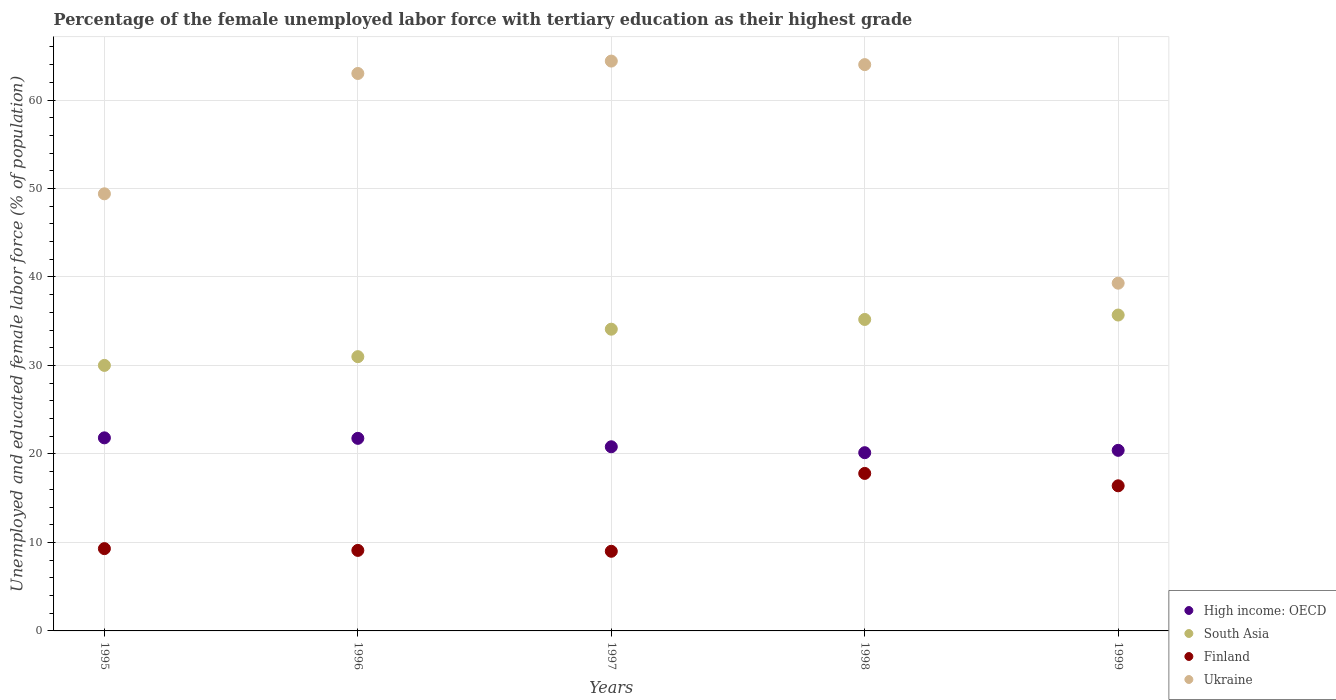How many different coloured dotlines are there?
Your answer should be compact. 4. What is the percentage of the unemployed female labor force with tertiary education in Finland in 1996?
Keep it short and to the point. 9.1. Across all years, what is the maximum percentage of the unemployed female labor force with tertiary education in High income: OECD?
Keep it short and to the point. 21.82. Across all years, what is the minimum percentage of the unemployed female labor force with tertiary education in South Asia?
Ensure brevity in your answer.  30.01. In which year was the percentage of the unemployed female labor force with tertiary education in South Asia maximum?
Offer a terse response. 1999. What is the total percentage of the unemployed female labor force with tertiary education in High income: OECD in the graph?
Give a very brief answer. 104.95. What is the difference between the percentage of the unemployed female labor force with tertiary education in High income: OECD in 1995 and that in 1999?
Keep it short and to the point. 1.41. What is the difference between the percentage of the unemployed female labor force with tertiary education in Finland in 1999 and the percentage of the unemployed female labor force with tertiary education in High income: OECD in 1996?
Your response must be concise. -5.36. What is the average percentage of the unemployed female labor force with tertiary education in High income: OECD per year?
Make the answer very short. 20.99. In the year 1999, what is the difference between the percentage of the unemployed female labor force with tertiary education in High income: OECD and percentage of the unemployed female labor force with tertiary education in Finland?
Your response must be concise. 4.01. What is the ratio of the percentage of the unemployed female labor force with tertiary education in Ukraine in 1997 to that in 1998?
Ensure brevity in your answer.  1.01. Is the percentage of the unemployed female labor force with tertiary education in High income: OECD in 1997 less than that in 1999?
Provide a succinct answer. No. Is the difference between the percentage of the unemployed female labor force with tertiary education in High income: OECD in 1996 and 1997 greater than the difference between the percentage of the unemployed female labor force with tertiary education in Finland in 1996 and 1997?
Offer a very short reply. Yes. What is the difference between the highest and the second highest percentage of the unemployed female labor force with tertiary education in South Asia?
Your answer should be compact. 0.5. What is the difference between the highest and the lowest percentage of the unemployed female labor force with tertiary education in High income: OECD?
Offer a terse response. 1.68. In how many years, is the percentage of the unemployed female labor force with tertiary education in High income: OECD greater than the average percentage of the unemployed female labor force with tertiary education in High income: OECD taken over all years?
Ensure brevity in your answer.  2. Is the sum of the percentage of the unemployed female labor force with tertiary education in Ukraine in 1995 and 1999 greater than the maximum percentage of the unemployed female labor force with tertiary education in High income: OECD across all years?
Provide a succinct answer. Yes. How many dotlines are there?
Keep it short and to the point. 4. How many years are there in the graph?
Give a very brief answer. 5. Does the graph contain any zero values?
Make the answer very short. No. How many legend labels are there?
Your response must be concise. 4. What is the title of the graph?
Make the answer very short. Percentage of the female unemployed labor force with tertiary education as their highest grade. What is the label or title of the Y-axis?
Offer a very short reply. Unemployed and educated female labor force (% of population). What is the Unemployed and educated female labor force (% of population) in High income: OECD in 1995?
Your response must be concise. 21.82. What is the Unemployed and educated female labor force (% of population) of South Asia in 1995?
Provide a short and direct response. 30.01. What is the Unemployed and educated female labor force (% of population) of Finland in 1995?
Make the answer very short. 9.3. What is the Unemployed and educated female labor force (% of population) in Ukraine in 1995?
Make the answer very short. 49.4. What is the Unemployed and educated female labor force (% of population) of High income: OECD in 1996?
Offer a very short reply. 21.76. What is the Unemployed and educated female labor force (% of population) in South Asia in 1996?
Keep it short and to the point. 30.99. What is the Unemployed and educated female labor force (% of population) in Finland in 1996?
Ensure brevity in your answer.  9.1. What is the Unemployed and educated female labor force (% of population) in Ukraine in 1996?
Provide a succinct answer. 63. What is the Unemployed and educated female labor force (% of population) of High income: OECD in 1997?
Offer a terse response. 20.81. What is the Unemployed and educated female labor force (% of population) in South Asia in 1997?
Your response must be concise. 34.1. What is the Unemployed and educated female labor force (% of population) in Ukraine in 1997?
Give a very brief answer. 64.4. What is the Unemployed and educated female labor force (% of population) of High income: OECD in 1998?
Provide a succinct answer. 20.14. What is the Unemployed and educated female labor force (% of population) of South Asia in 1998?
Give a very brief answer. 35.2. What is the Unemployed and educated female labor force (% of population) of Finland in 1998?
Provide a succinct answer. 17.8. What is the Unemployed and educated female labor force (% of population) of High income: OECD in 1999?
Offer a very short reply. 20.41. What is the Unemployed and educated female labor force (% of population) in South Asia in 1999?
Ensure brevity in your answer.  35.7. What is the Unemployed and educated female labor force (% of population) in Finland in 1999?
Offer a very short reply. 16.4. What is the Unemployed and educated female labor force (% of population) in Ukraine in 1999?
Your answer should be very brief. 39.3. Across all years, what is the maximum Unemployed and educated female labor force (% of population) in High income: OECD?
Provide a short and direct response. 21.82. Across all years, what is the maximum Unemployed and educated female labor force (% of population) in South Asia?
Ensure brevity in your answer.  35.7. Across all years, what is the maximum Unemployed and educated female labor force (% of population) of Finland?
Give a very brief answer. 17.8. Across all years, what is the maximum Unemployed and educated female labor force (% of population) of Ukraine?
Provide a succinct answer. 64.4. Across all years, what is the minimum Unemployed and educated female labor force (% of population) of High income: OECD?
Keep it short and to the point. 20.14. Across all years, what is the minimum Unemployed and educated female labor force (% of population) in South Asia?
Your answer should be compact. 30.01. Across all years, what is the minimum Unemployed and educated female labor force (% of population) of Finland?
Offer a terse response. 9. Across all years, what is the minimum Unemployed and educated female labor force (% of population) in Ukraine?
Ensure brevity in your answer.  39.3. What is the total Unemployed and educated female labor force (% of population) of High income: OECD in the graph?
Offer a very short reply. 104.95. What is the total Unemployed and educated female labor force (% of population) of South Asia in the graph?
Your answer should be compact. 166. What is the total Unemployed and educated female labor force (% of population) of Finland in the graph?
Provide a short and direct response. 61.6. What is the total Unemployed and educated female labor force (% of population) of Ukraine in the graph?
Your answer should be very brief. 280.1. What is the difference between the Unemployed and educated female labor force (% of population) in High income: OECD in 1995 and that in 1996?
Ensure brevity in your answer.  0.06. What is the difference between the Unemployed and educated female labor force (% of population) of South Asia in 1995 and that in 1996?
Your answer should be very brief. -0.99. What is the difference between the Unemployed and educated female labor force (% of population) of High income: OECD in 1995 and that in 1997?
Offer a terse response. 1.01. What is the difference between the Unemployed and educated female labor force (% of population) in South Asia in 1995 and that in 1997?
Provide a succinct answer. -4.09. What is the difference between the Unemployed and educated female labor force (% of population) of Finland in 1995 and that in 1997?
Provide a short and direct response. 0.3. What is the difference between the Unemployed and educated female labor force (% of population) in High income: OECD in 1995 and that in 1998?
Provide a short and direct response. 1.68. What is the difference between the Unemployed and educated female labor force (% of population) in South Asia in 1995 and that in 1998?
Provide a short and direct response. -5.19. What is the difference between the Unemployed and educated female labor force (% of population) in Finland in 1995 and that in 1998?
Your answer should be compact. -8.5. What is the difference between the Unemployed and educated female labor force (% of population) of Ukraine in 1995 and that in 1998?
Offer a terse response. -14.6. What is the difference between the Unemployed and educated female labor force (% of population) in High income: OECD in 1995 and that in 1999?
Your answer should be very brief. 1.41. What is the difference between the Unemployed and educated female labor force (% of population) in South Asia in 1995 and that in 1999?
Your answer should be very brief. -5.69. What is the difference between the Unemployed and educated female labor force (% of population) of High income: OECD in 1996 and that in 1997?
Your answer should be compact. 0.95. What is the difference between the Unemployed and educated female labor force (% of population) of South Asia in 1996 and that in 1997?
Provide a short and direct response. -3.11. What is the difference between the Unemployed and educated female labor force (% of population) of Finland in 1996 and that in 1997?
Offer a very short reply. 0.1. What is the difference between the Unemployed and educated female labor force (% of population) of Ukraine in 1996 and that in 1997?
Ensure brevity in your answer.  -1.4. What is the difference between the Unemployed and educated female labor force (% of population) in High income: OECD in 1996 and that in 1998?
Provide a short and direct response. 1.62. What is the difference between the Unemployed and educated female labor force (% of population) in South Asia in 1996 and that in 1998?
Provide a short and direct response. -4.21. What is the difference between the Unemployed and educated female labor force (% of population) of Ukraine in 1996 and that in 1998?
Provide a succinct answer. -1. What is the difference between the Unemployed and educated female labor force (% of population) of High income: OECD in 1996 and that in 1999?
Provide a short and direct response. 1.36. What is the difference between the Unemployed and educated female labor force (% of population) in South Asia in 1996 and that in 1999?
Make the answer very short. -4.71. What is the difference between the Unemployed and educated female labor force (% of population) in Finland in 1996 and that in 1999?
Keep it short and to the point. -7.3. What is the difference between the Unemployed and educated female labor force (% of population) of Ukraine in 1996 and that in 1999?
Keep it short and to the point. 23.7. What is the difference between the Unemployed and educated female labor force (% of population) of High income: OECD in 1997 and that in 1998?
Make the answer very short. 0.67. What is the difference between the Unemployed and educated female labor force (% of population) of South Asia in 1997 and that in 1998?
Provide a succinct answer. -1.1. What is the difference between the Unemployed and educated female labor force (% of population) of Ukraine in 1997 and that in 1998?
Provide a short and direct response. 0.4. What is the difference between the Unemployed and educated female labor force (% of population) of High income: OECD in 1997 and that in 1999?
Your response must be concise. 0.4. What is the difference between the Unemployed and educated female labor force (% of population) in Ukraine in 1997 and that in 1999?
Give a very brief answer. 25.1. What is the difference between the Unemployed and educated female labor force (% of population) in High income: OECD in 1998 and that in 1999?
Offer a terse response. -0.27. What is the difference between the Unemployed and educated female labor force (% of population) of Ukraine in 1998 and that in 1999?
Your answer should be compact. 24.7. What is the difference between the Unemployed and educated female labor force (% of population) of High income: OECD in 1995 and the Unemployed and educated female labor force (% of population) of South Asia in 1996?
Give a very brief answer. -9.17. What is the difference between the Unemployed and educated female labor force (% of population) in High income: OECD in 1995 and the Unemployed and educated female labor force (% of population) in Finland in 1996?
Keep it short and to the point. 12.72. What is the difference between the Unemployed and educated female labor force (% of population) of High income: OECD in 1995 and the Unemployed and educated female labor force (% of population) of Ukraine in 1996?
Your answer should be compact. -41.18. What is the difference between the Unemployed and educated female labor force (% of population) in South Asia in 1995 and the Unemployed and educated female labor force (% of population) in Finland in 1996?
Offer a very short reply. 20.91. What is the difference between the Unemployed and educated female labor force (% of population) in South Asia in 1995 and the Unemployed and educated female labor force (% of population) in Ukraine in 1996?
Ensure brevity in your answer.  -32.99. What is the difference between the Unemployed and educated female labor force (% of population) of Finland in 1995 and the Unemployed and educated female labor force (% of population) of Ukraine in 1996?
Your answer should be compact. -53.7. What is the difference between the Unemployed and educated female labor force (% of population) in High income: OECD in 1995 and the Unemployed and educated female labor force (% of population) in South Asia in 1997?
Keep it short and to the point. -12.28. What is the difference between the Unemployed and educated female labor force (% of population) of High income: OECD in 1995 and the Unemployed and educated female labor force (% of population) of Finland in 1997?
Ensure brevity in your answer.  12.82. What is the difference between the Unemployed and educated female labor force (% of population) in High income: OECD in 1995 and the Unemployed and educated female labor force (% of population) in Ukraine in 1997?
Give a very brief answer. -42.58. What is the difference between the Unemployed and educated female labor force (% of population) in South Asia in 1995 and the Unemployed and educated female labor force (% of population) in Finland in 1997?
Make the answer very short. 21.01. What is the difference between the Unemployed and educated female labor force (% of population) in South Asia in 1995 and the Unemployed and educated female labor force (% of population) in Ukraine in 1997?
Give a very brief answer. -34.39. What is the difference between the Unemployed and educated female labor force (% of population) of Finland in 1995 and the Unemployed and educated female labor force (% of population) of Ukraine in 1997?
Ensure brevity in your answer.  -55.1. What is the difference between the Unemployed and educated female labor force (% of population) of High income: OECD in 1995 and the Unemployed and educated female labor force (% of population) of South Asia in 1998?
Provide a short and direct response. -13.38. What is the difference between the Unemployed and educated female labor force (% of population) of High income: OECD in 1995 and the Unemployed and educated female labor force (% of population) of Finland in 1998?
Make the answer very short. 4.02. What is the difference between the Unemployed and educated female labor force (% of population) in High income: OECD in 1995 and the Unemployed and educated female labor force (% of population) in Ukraine in 1998?
Provide a succinct answer. -42.18. What is the difference between the Unemployed and educated female labor force (% of population) in South Asia in 1995 and the Unemployed and educated female labor force (% of population) in Finland in 1998?
Provide a short and direct response. 12.21. What is the difference between the Unemployed and educated female labor force (% of population) of South Asia in 1995 and the Unemployed and educated female labor force (% of population) of Ukraine in 1998?
Keep it short and to the point. -33.99. What is the difference between the Unemployed and educated female labor force (% of population) in Finland in 1995 and the Unemployed and educated female labor force (% of population) in Ukraine in 1998?
Offer a terse response. -54.7. What is the difference between the Unemployed and educated female labor force (% of population) in High income: OECD in 1995 and the Unemployed and educated female labor force (% of population) in South Asia in 1999?
Offer a very short reply. -13.88. What is the difference between the Unemployed and educated female labor force (% of population) of High income: OECD in 1995 and the Unemployed and educated female labor force (% of population) of Finland in 1999?
Your answer should be very brief. 5.42. What is the difference between the Unemployed and educated female labor force (% of population) of High income: OECD in 1995 and the Unemployed and educated female labor force (% of population) of Ukraine in 1999?
Your response must be concise. -17.48. What is the difference between the Unemployed and educated female labor force (% of population) in South Asia in 1995 and the Unemployed and educated female labor force (% of population) in Finland in 1999?
Give a very brief answer. 13.61. What is the difference between the Unemployed and educated female labor force (% of population) in South Asia in 1995 and the Unemployed and educated female labor force (% of population) in Ukraine in 1999?
Your answer should be very brief. -9.29. What is the difference between the Unemployed and educated female labor force (% of population) of High income: OECD in 1996 and the Unemployed and educated female labor force (% of population) of South Asia in 1997?
Provide a succinct answer. -12.34. What is the difference between the Unemployed and educated female labor force (% of population) in High income: OECD in 1996 and the Unemployed and educated female labor force (% of population) in Finland in 1997?
Offer a very short reply. 12.76. What is the difference between the Unemployed and educated female labor force (% of population) of High income: OECD in 1996 and the Unemployed and educated female labor force (% of population) of Ukraine in 1997?
Offer a terse response. -42.64. What is the difference between the Unemployed and educated female labor force (% of population) in South Asia in 1996 and the Unemployed and educated female labor force (% of population) in Finland in 1997?
Your answer should be very brief. 21.99. What is the difference between the Unemployed and educated female labor force (% of population) of South Asia in 1996 and the Unemployed and educated female labor force (% of population) of Ukraine in 1997?
Make the answer very short. -33.41. What is the difference between the Unemployed and educated female labor force (% of population) in Finland in 1996 and the Unemployed and educated female labor force (% of population) in Ukraine in 1997?
Your answer should be very brief. -55.3. What is the difference between the Unemployed and educated female labor force (% of population) in High income: OECD in 1996 and the Unemployed and educated female labor force (% of population) in South Asia in 1998?
Offer a terse response. -13.44. What is the difference between the Unemployed and educated female labor force (% of population) of High income: OECD in 1996 and the Unemployed and educated female labor force (% of population) of Finland in 1998?
Give a very brief answer. 3.96. What is the difference between the Unemployed and educated female labor force (% of population) in High income: OECD in 1996 and the Unemployed and educated female labor force (% of population) in Ukraine in 1998?
Provide a short and direct response. -42.24. What is the difference between the Unemployed and educated female labor force (% of population) of South Asia in 1996 and the Unemployed and educated female labor force (% of population) of Finland in 1998?
Your response must be concise. 13.19. What is the difference between the Unemployed and educated female labor force (% of population) of South Asia in 1996 and the Unemployed and educated female labor force (% of population) of Ukraine in 1998?
Make the answer very short. -33.01. What is the difference between the Unemployed and educated female labor force (% of population) of Finland in 1996 and the Unemployed and educated female labor force (% of population) of Ukraine in 1998?
Your response must be concise. -54.9. What is the difference between the Unemployed and educated female labor force (% of population) in High income: OECD in 1996 and the Unemployed and educated female labor force (% of population) in South Asia in 1999?
Provide a short and direct response. -13.94. What is the difference between the Unemployed and educated female labor force (% of population) in High income: OECD in 1996 and the Unemployed and educated female labor force (% of population) in Finland in 1999?
Your response must be concise. 5.36. What is the difference between the Unemployed and educated female labor force (% of population) of High income: OECD in 1996 and the Unemployed and educated female labor force (% of population) of Ukraine in 1999?
Ensure brevity in your answer.  -17.54. What is the difference between the Unemployed and educated female labor force (% of population) of South Asia in 1996 and the Unemployed and educated female labor force (% of population) of Finland in 1999?
Make the answer very short. 14.59. What is the difference between the Unemployed and educated female labor force (% of population) of South Asia in 1996 and the Unemployed and educated female labor force (% of population) of Ukraine in 1999?
Your answer should be compact. -8.31. What is the difference between the Unemployed and educated female labor force (% of population) of Finland in 1996 and the Unemployed and educated female labor force (% of population) of Ukraine in 1999?
Your answer should be compact. -30.2. What is the difference between the Unemployed and educated female labor force (% of population) in High income: OECD in 1997 and the Unemployed and educated female labor force (% of population) in South Asia in 1998?
Ensure brevity in your answer.  -14.39. What is the difference between the Unemployed and educated female labor force (% of population) of High income: OECD in 1997 and the Unemployed and educated female labor force (% of population) of Finland in 1998?
Your answer should be very brief. 3.01. What is the difference between the Unemployed and educated female labor force (% of population) in High income: OECD in 1997 and the Unemployed and educated female labor force (% of population) in Ukraine in 1998?
Provide a short and direct response. -43.19. What is the difference between the Unemployed and educated female labor force (% of population) of South Asia in 1997 and the Unemployed and educated female labor force (% of population) of Ukraine in 1998?
Provide a succinct answer. -29.9. What is the difference between the Unemployed and educated female labor force (% of population) of Finland in 1997 and the Unemployed and educated female labor force (% of population) of Ukraine in 1998?
Your response must be concise. -55. What is the difference between the Unemployed and educated female labor force (% of population) of High income: OECD in 1997 and the Unemployed and educated female labor force (% of population) of South Asia in 1999?
Give a very brief answer. -14.89. What is the difference between the Unemployed and educated female labor force (% of population) of High income: OECD in 1997 and the Unemployed and educated female labor force (% of population) of Finland in 1999?
Your answer should be compact. 4.41. What is the difference between the Unemployed and educated female labor force (% of population) in High income: OECD in 1997 and the Unemployed and educated female labor force (% of population) in Ukraine in 1999?
Make the answer very short. -18.49. What is the difference between the Unemployed and educated female labor force (% of population) in South Asia in 1997 and the Unemployed and educated female labor force (% of population) in Finland in 1999?
Give a very brief answer. 17.7. What is the difference between the Unemployed and educated female labor force (% of population) in Finland in 1997 and the Unemployed and educated female labor force (% of population) in Ukraine in 1999?
Offer a terse response. -30.3. What is the difference between the Unemployed and educated female labor force (% of population) in High income: OECD in 1998 and the Unemployed and educated female labor force (% of population) in South Asia in 1999?
Give a very brief answer. -15.56. What is the difference between the Unemployed and educated female labor force (% of population) of High income: OECD in 1998 and the Unemployed and educated female labor force (% of population) of Finland in 1999?
Give a very brief answer. 3.74. What is the difference between the Unemployed and educated female labor force (% of population) in High income: OECD in 1998 and the Unemployed and educated female labor force (% of population) in Ukraine in 1999?
Your answer should be very brief. -19.16. What is the difference between the Unemployed and educated female labor force (% of population) of South Asia in 1998 and the Unemployed and educated female labor force (% of population) of Ukraine in 1999?
Offer a very short reply. -4.1. What is the difference between the Unemployed and educated female labor force (% of population) in Finland in 1998 and the Unemployed and educated female labor force (% of population) in Ukraine in 1999?
Ensure brevity in your answer.  -21.5. What is the average Unemployed and educated female labor force (% of population) in High income: OECD per year?
Provide a succinct answer. 20.99. What is the average Unemployed and educated female labor force (% of population) of South Asia per year?
Offer a terse response. 33.2. What is the average Unemployed and educated female labor force (% of population) of Finland per year?
Your answer should be compact. 12.32. What is the average Unemployed and educated female labor force (% of population) of Ukraine per year?
Your answer should be very brief. 56.02. In the year 1995, what is the difference between the Unemployed and educated female labor force (% of population) in High income: OECD and Unemployed and educated female labor force (% of population) in South Asia?
Provide a short and direct response. -8.19. In the year 1995, what is the difference between the Unemployed and educated female labor force (% of population) of High income: OECD and Unemployed and educated female labor force (% of population) of Finland?
Keep it short and to the point. 12.52. In the year 1995, what is the difference between the Unemployed and educated female labor force (% of population) of High income: OECD and Unemployed and educated female labor force (% of population) of Ukraine?
Keep it short and to the point. -27.58. In the year 1995, what is the difference between the Unemployed and educated female labor force (% of population) in South Asia and Unemployed and educated female labor force (% of population) in Finland?
Provide a succinct answer. 20.71. In the year 1995, what is the difference between the Unemployed and educated female labor force (% of population) of South Asia and Unemployed and educated female labor force (% of population) of Ukraine?
Offer a very short reply. -19.39. In the year 1995, what is the difference between the Unemployed and educated female labor force (% of population) in Finland and Unemployed and educated female labor force (% of population) in Ukraine?
Make the answer very short. -40.1. In the year 1996, what is the difference between the Unemployed and educated female labor force (% of population) of High income: OECD and Unemployed and educated female labor force (% of population) of South Asia?
Make the answer very short. -9.23. In the year 1996, what is the difference between the Unemployed and educated female labor force (% of population) of High income: OECD and Unemployed and educated female labor force (% of population) of Finland?
Offer a terse response. 12.66. In the year 1996, what is the difference between the Unemployed and educated female labor force (% of population) in High income: OECD and Unemployed and educated female labor force (% of population) in Ukraine?
Provide a short and direct response. -41.24. In the year 1996, what is the difference between the Unemployed and educated female labor force (% of population) in South Asia and Unemployed and educated female labor force (% of population) in Finland?
Offer a terse response. 21.89. In the year 1996, what is the difference between the Unemployed and educated female labor force (% of population) of South Asia and Unemployed and educated female labor force (% of population) of Ukraine?
Your answer should be compact. -32.01. In the year 1996, what is the difference between the Unemployed and educated female labor force (% of population) in Finland and Unemployed and educated female labor force (% of population) in Ukraine?
Make the answer very short. -53.9. In the year 1997, what is the difference between the Unemployed and educated female labor force (% of population) in High income: OECD and Unemployed and educated female labor force (% of population) in South Asia?
Offer a very short reply. -13.29. In the year 1997, what is the difference between the Unemployed and educated female labor force (% of population) of High income: OECD and Unemployed and educated female labor force (% of population) of Finland?
Your response must be concise. 11.81. In the year 1997, what is the difference between the Unemployed and educated female labor force (% of population) in High income: OECD and Unemployed and educated female labor force (% of population) in Ukraine?
Your answer should be compact. -43.59. In the year 1997, what is the difference between the Unemployed and educated female labor force (% of population) in South Asia and Unemployed and educated female labor force (% of population) in Finland?
Your answer should be compact. 25.1. In the year 1997, what is the difference between the Unemployed and educated female labor force (% of population) of South Asia and Unemployed and educated female labor force (% of population) of Ukraine?
Your answer should be compact. -30.3. In the year 1997, what is the difference between the Unemployed and educated female labor force (% of population) of Finland and Unemployed and educated female labor force (% of population) of Ukraine?
Make the answer very short. -55.4. In the year 1998, what is the difference between the Unemployed and educated female labor force (% of population) in High income: OECD and Unemployed and educated female labor force (% of population) in South Asia?
Make the answer very short. -15.06. In the year 1998, what is the difference between the Unemployed and educated female labor force (% of population) in High income: OECD and Unemployed and educated female labor force (% of population) in Finland?
Provide a short and direct response. 2.34. In the year 1998, what is the difference between the Unemployed and educated female labor force (% of population) in High income: OECD and Unemployed and educated female labor force (% of population) in Ukraine?
Your response must be concise. -43.86. In the year 1998, what is the difference between the Unemployed and educated female labor force (% of population) in South Asia and Unemployed and educated female labor force (% of population) in Finland?
Provide a succinct answer. 17.4. In the year 1998, what is the difference between the Unemployed and educated female labor force (% of population) in South Asia and Unemployed and educated female labor force (% of population) in Ukraine?
Provide a succinct answer. -28.8. In the year 1998, what is the difference between the Unemployed and educated female labor force (% of population) of Finland and Unemployed and educated female labor force (% of population) of Ukraine?
Ensure brevity in your answer.  -46.2. In the year 1999, what is the difference between the Unemployed and educated female labor force (% of population) in High income: OECD and Unemployed and educated female labor force (% of population) in South Asia?
Your answer should be very brief. -15.29. In the year 1999, what is the difference between the Unemployed and educated female labor force (% of population) in High income: OECD and Unemployed and educated female labor force (% of population) in Finland?
Ensure brevity in your answer.  4.01. In the year 1999, what is the difference between the Unemployed and educated female labor force (% of population) of High income: OECD and Unemployed and educated female labor force (% of population) of Ukraine?
Provide a succinct answer. -18.89. In the year 1999, what is the difference between the Unemployed and educated female labor force (% of population) in South Asia and Unemployed and educated female labor force (% of population) in Finland?
Your response must be concise. 19.3. In the year 1999, what is the difference between the Unemployed and educated female labor force (% of population) in Finland and Unemployed and educated female labor force (% of population) in Ukraine?
Give a very brief answer. -22.9. What is the ratio of the Unemployed and educated female labor force (% of population) in South Asia in 1995 to that in 1996?
Your response must be concise. 0.97. What is the ratio of the Unemployed and educated female labor force (% of population) of Ukraine in 1995 to that in 1996?
Provide a short and direct response. 0.78. What is the ratio of the Unemployed and educated female labor force (% of population) in High income: OECD in 1995 to that in 1997?
Offer a terse response. 1.05. What is the ratio of the Unemployed and educated female labor force (% of population) in Finland in 1995 to that in 1997?
Your response must be concise. 1.03. What is the ratio of the Unemployed and educated female labor force (% of population) in Ukraine in 1995 to that in 1997?
Provide a short and direct response. 0.77. What is the ratio of the Unemployed and educated female labor force (% of population) of South Asia in 1995 to that in 1998?
Offer a very short reply. 0.85. What is the ratio of the Unemployed and educated female labor force (% of population) in Finland in 1995 to that in 1998?
Make the answer very short. 0.52. What is the ratio of the Unemployed and educated female labor force (% of population) of Ukraine in 1995 to that in 1998?
Offer a very short reply. 0.77. What is the ratio of the Unemployed and educated female labor force (% of population) in High income: OECD in 1995 to that in 1999?
Provide a short and direct response. 1.07. What is the ratio of the Unemployed and educated female labor force (% of population) of South Asia in 1995 to that in 1999?
Your response must be concise. 0.84. What is the ratio of the Unemployed and educated female labor force (% of population) of Finland in 1995 to that in 1999?
Provide a short and direct response. 0.57. What is the ratio of the Unemployed and educated female labor force (% of population) of Ukraine in 1995 to that in 1999?
Your answer should be compact. 1.26. What is the ratio of the Unemployed and educated female labor force (% of population) in High income: OECD in 1996 to that in 1997?
Provide a succinct answer. 1.05. What is the ratio of the Unemployed and educated female labor force (% of population) of South Asia in 1996 to that in 1997?
Provide a short and direct response. 0.91. What is the ratio of the Unemployed and educated female labor force (% of population) of Finland in 1996 to that in 1997?
Your answer should be compact. 1.01. What is the ratio of the Unemployed and educated female labor force (% of population) of Ukraine in 1996 to that in 1997?
Provide a short and direct response. 0.98. What is the ratio of the Unemployed and educated female labor force (% of population) of High income: OECD in 1996 to that in 1998?
Your answer should be compact. 1.08. What is the ratio of the Unemployed and educated female labor force (% of population) in South Asia in 1996 to that in 1998?
Offer a terse response. 0.88. What is the ratio of the Unemployed and educated female labor force (% of population) in Finland in 1996 to that in 1998?
Provide a succinct answer. 0.51. What is the ratio of the Unemployed and educated female labor force (% of population) in Ukraine in 1996 to that in 1998?
Provide a short and direct response. 0.98. What is the ratio of the Unemployed and educated female labor force (% of population) of High income: OECD in 1996 to that in 1999?
Your answer should be compact. 1.07. What is the ratio of the Unemployed and educated female labor force (% of population) of South Asia in 1996 to that in 1999?
Provide a succinct answer. 0.87. What is the ratio of the Unemployed and educated female labor force (% of population) of Finland in 1996 to that in 1999?
Your answer should be very brief. 0.55. What is the ratio of the Unemployed and educated female labor force (% of population) of Ukraine in 1996 to that in 1999?
Give a very brief answer. 1.6. What is the ratio of the Unemployed and educated female labor force (% of population) of High income: OECD in 1997 to that in 1998?
Ensure brevity in your answer.  1.03. What is the ratio of the Unemployed and educated female labor force (% of population) of South Asia in 1997 to that in 1998?
Give a very brief answer. 0.97. What is the ratio of the Unemployed and educated female labor force (% of population) of Finland in 1997 to that in 1998?
Give a very brief answer. 0.51. What is the ratio of the Unemployed and educated female labor force (% of population) in High income: OECD in 1997 to that in 1999?
Provide a short and direct response. 1.02. What is the ratio of the Unemployed and educated female labor force (% of population) in South Asia in 1997 to that in 1999?
Offer a terse response. 0.96. What is the ratio of the Unemployed and educated female labor force (% of population) of Finland in 1997 to that in 1999?
Make the answer very short. 0.55. What is the ratio of the Unemployed and educated female labor force (% of population) in Ukraine in 1997 to that in 1999?
Offer a terse response. 1.64. What is the ratio of the Unemployed and educated female labor force (% of population) in South Asia in 1998 to that in 1999?
Your answer should be compact. 0.99. What is the ratio of the Unemployed and educated female labor force (% of population) of Finland in 1998 to that in 1999?
Offer a very short reply. 1.09. What is the ratio of the Unemployed and educated female labor force (% of population) in Ukraine in 1998 to that in 1999?
Offer a very short reply. 1.63. What is the difference between the highest and the second highest Unemployed and educated female labor force (% of population) of High income: OECD?
Offer a very short reply. 0.06. What is the difference between the highest and the lowest Unemployed and educated female labor force (% of population) in High income: OECD?
Make the answer very short. 1.68. What is the difference between the highest and the lowest Unemployed and educated female labor force (% of population) of South Asia?
Keep it short and to the point. 5.69. What is the difference between the highest and the lowest Unemployed and educated female labor force (% of population) of Ukraine?
Ensure brevity in your answer.  25.1. 